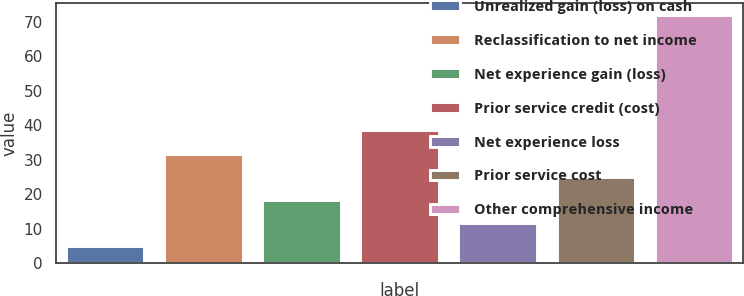Convert chart. <chart><loc_0><loc_0><loc_500><loc_500><bar_chart><fcel>Unrealized gain (loss) on cash<fcel>Reclassification to net income<fcel>Net experience gain (loss)<fcel>Prior service credit (cost)<fcel>Net experience loss<fcel>Prior service cost<fcel>Other comprehensive income<nl><fcel>5<fcel>31.8<fcel>18.4<fcel>38.5<fcel>11.7<fcel>25.1<fcel>72<nl></chart> 